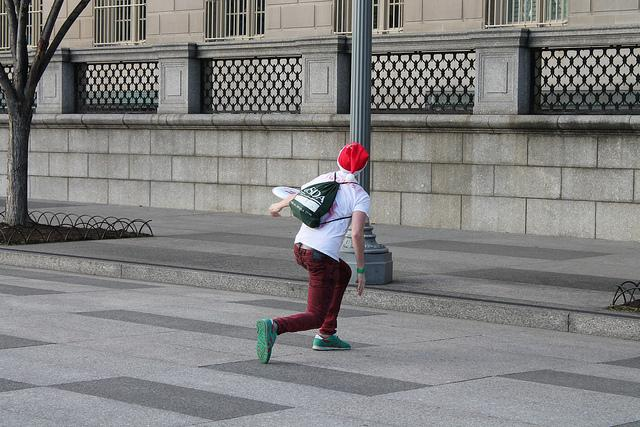What is the man doing? Please explain your reasoning. running. The man is running since his feet are off the ground. 